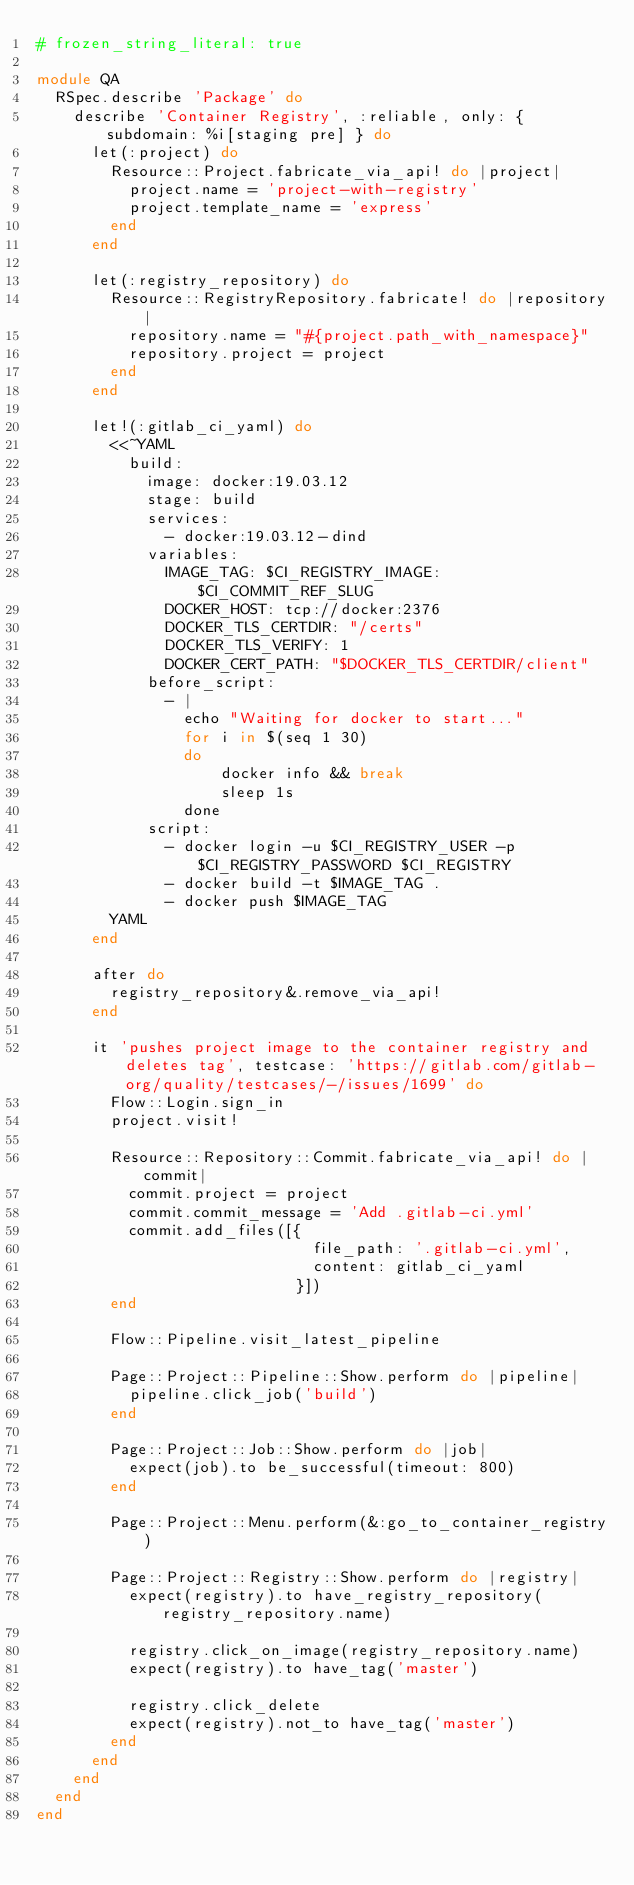Convert code to text. <code><loc_0><loc_0><loc_500><loc_500><_Ruby_># frozen_string_literal: true

module QA
  RSpec.describe 'Package' do
    describe 'Container Registry', :reliable, only: { subdomain: %i[staging pre] } do
      let(:project) do
        Resource::Project.fabricate_via_api! do |project|
          project.name = 'project-with-registry'
          project.template_name = 'express'
        end
      end

      let(:registry_repository) do
        Resource::RegistryRepository.fabricate! do |repository|
          repository.name = "#{project.path_with_namespace}"
          repository.project = project
        end
      end

      let!(:gitlab_ci_yaml) do
        <<~YAML
          build:
            image: docker:19.03.12
            stage: build
            services:
              - docker:19.03.12-dind
            variables:
              IMAGE_TAG: $CI_REGISTRY_IMAGE:$CI_COMMIT_REF_SLUG
              DOCKER_HOST: tcp://docker:2376
              DOCKER_TLS_CERTDIR: "/certs"
              DOCKER_TLS_VERIFY: 1
              DOCKER_CERT_PATH: "$DOCKER_TLS_CERTDIR/client"
            before_script:
              - |
                echo "Waiting for docker to start..."
                for i in $(seq 1 30)
                do
                    docker info && break
                    sleep 1s
                done       
            script:
              - docker login -u $CI_REGISTRY_USER -p $CI_REGISTRY_PASSWORD $CI_REGISTRY
              - docker build -t $IMAGE_TAG .
              - docker push $IMAGE_TAG
        YAML
      end

      after do
        registry_repository&.remove_via_api!
      end

      it 'pushes project image to the container registry and deletes tag', testcase: 'https://gitlab.com/gitlab-org/quality/testcases/-/issues/1699' do
        Flow::Login.sign_in
        project.visit!

        Resource::Repository::Commit.fabricate_via_api! do |commit|
          commit.project = project
          commit.commit_message = 'Add .gitlab-ci.yml'
          commit.add_files([{
                              file_path: '.gitlab-ci.yml',
                              content: gitlab_ci_yaml
                            }])
        end

        Flow::Pipeline.visit_latest_pipeline

        Page::Project::Pipeline::Show.perform do |pipeline|
          pipeline.click_job('build')
        end

        Page::Project::Job::Show.perform do |job|
          expect(job).to be_successful(timeout: 800)
        end

        Page::Project::Menu.perform(&:go_to_container_registry)

        Page::Project::Registry::Show.perform do |registry|
          expect(registry).to have_registry_repository(registry_repository.name)

          registry.click_on_image(registry_repository.name)
          expect(registry).to have_tag('master')

          registry.click_delete
          expect(registry).not_to have_tag('master')
        end
      end
    end
  end
end
</code> 